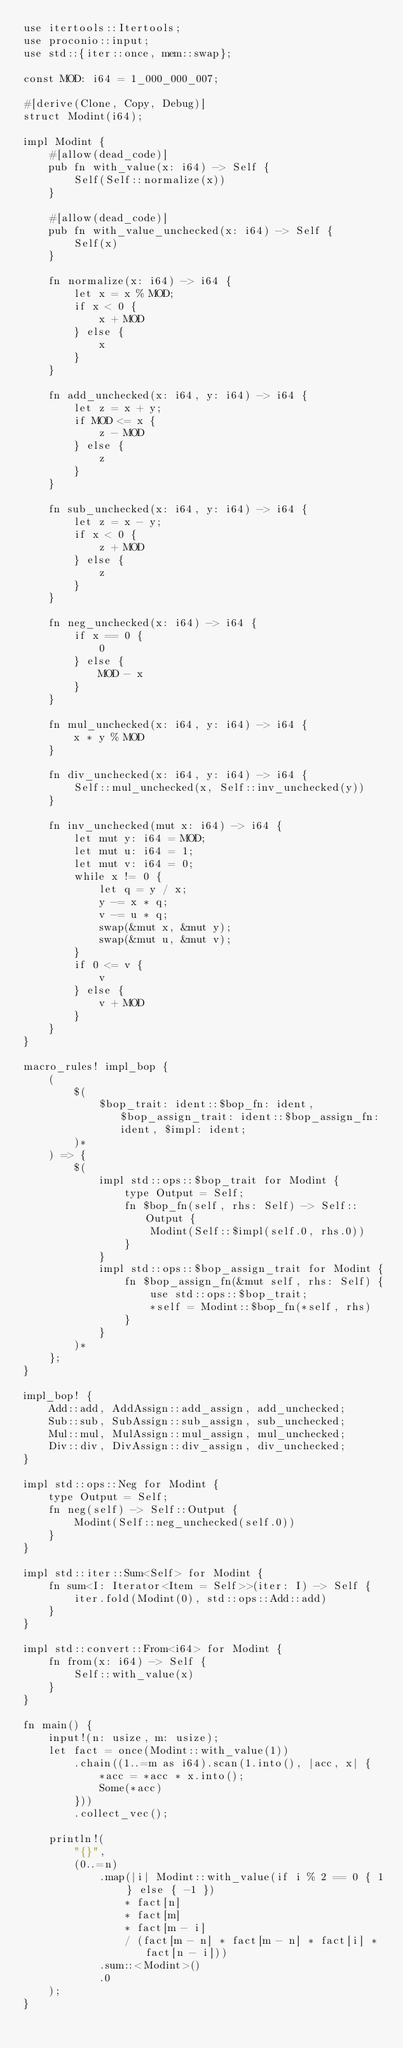<code> <loc_0><loc_0><loc_500><loc_500><_Rust_>use itertools::Itertools;
use proconio::input;
use std::{iter::once, mem::swap};

const MOD: i64 = 1_000_000_007;

#[derive(Clone, Copy, Debug)]
struct Modint(i64);

impl Modint {
    #[allow(dead_code)]
    pub fn with_value(x: i64) -> Self {
        Self(Self::normalize(x))
    }

    #[allow(dead_code)]
    pub fn with_value_unchecked(x: i64) -> Self {
        Self(x)
    }

    fn normalize(x: i64) -> i64 {
        let x = x % MOD;
        if x < 0 {
            x + MOD
        } else {
            x
        }
    }

    fn add_unchecked(x: i64, y: i64) -> i64 {
        let z = x + y;
        if MOD <= x {
            z - MOD
        } else {
            z
        }
    }

    fn sub_unchecked(x: i64, y: i64) -> i64 {
        let z = x - y;
        if x < 0 {
            z + MOD
        } else {
            z
        }
    }

    fn neg_unchecked(x: i64) -> i64 {
        if x == 0 {
            0
        } else {
            MOD - x
        }
    }

    fn mul_unchecked(x: i64, y: i64) -> i64 {
        x * y % MOD
    }

    fn div_unchecked(x: i64, y: i64) -> i64 {
        Self::mul_unchecked(x, Self::inv_unchecked(y))
    }

    fn inv_unchecked(mut x: i64) -> i64 {
        let mut y: i64 = MOD;
        let mut u: i64 = 1;
        let mut v: i64 = 0;
        while x != 0 {
            let q = y / x;
            y -= x * q;
            v -= u * q;
            swap(&mut x, &mut y);
            swap(&mut u, &mut v);
        }
        if 0 <= v {
            v
        } else {
            v + MOD
        }
    }
}

macro_rules! impl_bop {
    (
        $(
            $bop_trait: ident::$bop_fn: ident, $bop_assign_trait: ident::$bop_assign_fn: ident, $impl: ident;
        )*
    ) => {
        $(
            impl std::ops::$bop_trait for Modint {
                type Output = Self;
                fn $bop_fn(self, rhs: Self) -> Self::Output {
                    Modint(Self::$impl(self.0, rhs.0))
                }
            }
            impl std::ops::$bop_assign_trait for Modint {
                fn $bop_assign_fn(&mut self, rhs: Self) {
                    use std::ops::$bop_trait;
                    *self = Modint::$bop_fn(*self, rhs)
                }
            }
        )*
    };
}

impl_bop! {
    Add::add, AddAssign::add_assign, add_unchecked;
    Sub::sub, SubAssign::sub_assign, sub_unchecked;
    Mul::mul, MulAssign::mul_assign, mul_unchecked;
    Div::div, DivAssign::div_assign, div_unchecked;
}

impl std::ops::Neg for Modint {
    type Output = Self;
    fn neg(self) -> Self::Output {
        Modint(Self::neg_unchecked(self.0))
    }
}

impl std::iter::Sum<Self> for Modint {
    fn sum<I: Iterator<Item = Self>>(iter: I) -> Self {
        iter.fold(Modint(0), std::ops::Add::add)
    }
}

impl std::convert::From<i64> for Modint {
    fn from(x: i64) -> Self {
        Self::with_value(x)
    }
}

fn main() {
    input!(n: usize, m: usize);
    let fact = once(Modint::with_value(1))
        .chain((1..=m as i64).scan(1.into(), |acc, x| {
            *acc = *acc * x.into();
            Some(*acc)
        }))
        .collect_vec();

    println!(
        "{}",
        (0..=n)
            .map(|i| Modint::with_value(if i % 2 == 0 { 1 } else { -1 })
                * fact[n]
                * fact[m]
                * fact[m - i]
                / (fact[m - n] * fact[m - n] * fact[i] * fact[n - i]))
            .sum::<Modint>()
            .0
    );
}
</code> 